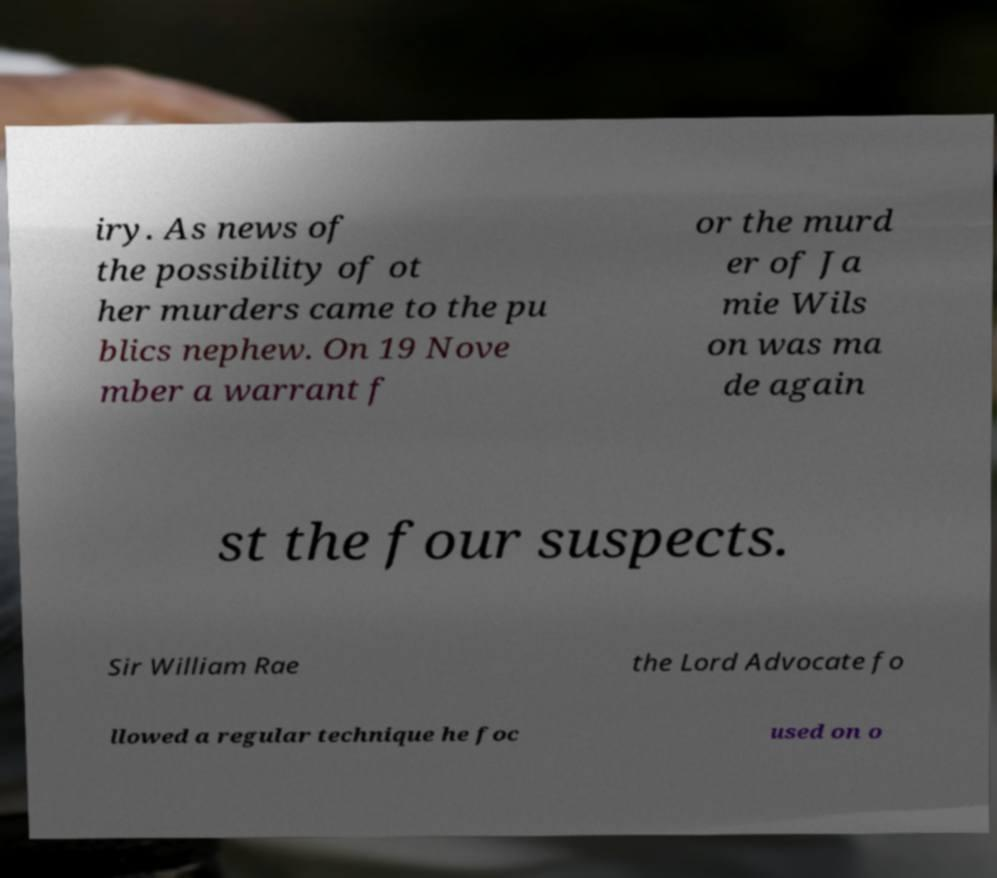Please identify and transcribe the text found in this image. iry. As news of the possibility of ot her murders came to the pu blics nephew. On 19 Nove mber a warrant f or the murd er of Ja mie Wils on was ma de again st the four suspects. Sir William Rae the Lord Advocate fo llowed a regular technique he foc used on o 